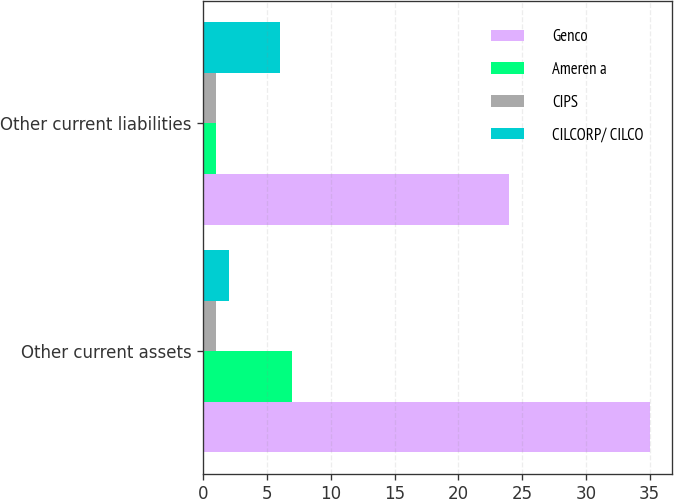Convert chart to OTSL. <chart><loc_0><loc_0><loc_500><loc_500><stacked_bar_chart><ecel><fcel>Other current assets<fcel>Other current liabilities<nl><fcel>Genco<fcel>35<fcel>24<nl><fcel>Ameren a<fcel>7<fcel>1<nl><fcel>CIPS<fcel>1<fcel>1<nl><fcel>CILCORP/ CILCO<fcel>2<fcel>6<nl></chart> 